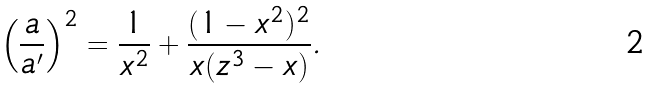Convert formula to latex. <formula><loc_0><loc_0><loc_500><loc_500>\left ( \frac { a } { a ^ { \prime } } \right ) ^ { 2 } = \frac { 1 } { x ^ { 2 } } + \frac { ( 1 - x ^ { 2 } ) ^ { 2 } } { x ( z ^ { 3 } - x ) } .</formula> 